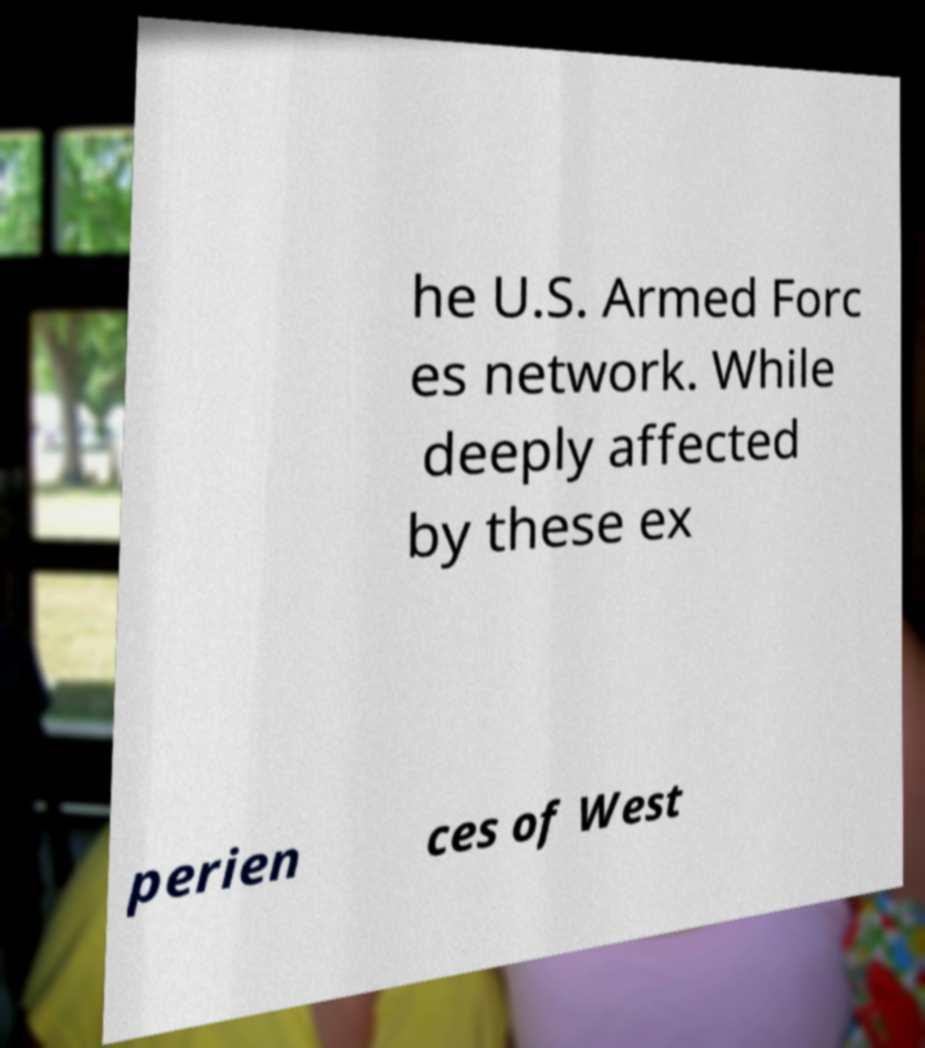Please read and relay the text visible in this image. What does it say? he U.S. Armed Forc es network. While deeply affected by these ex perien ces of West 